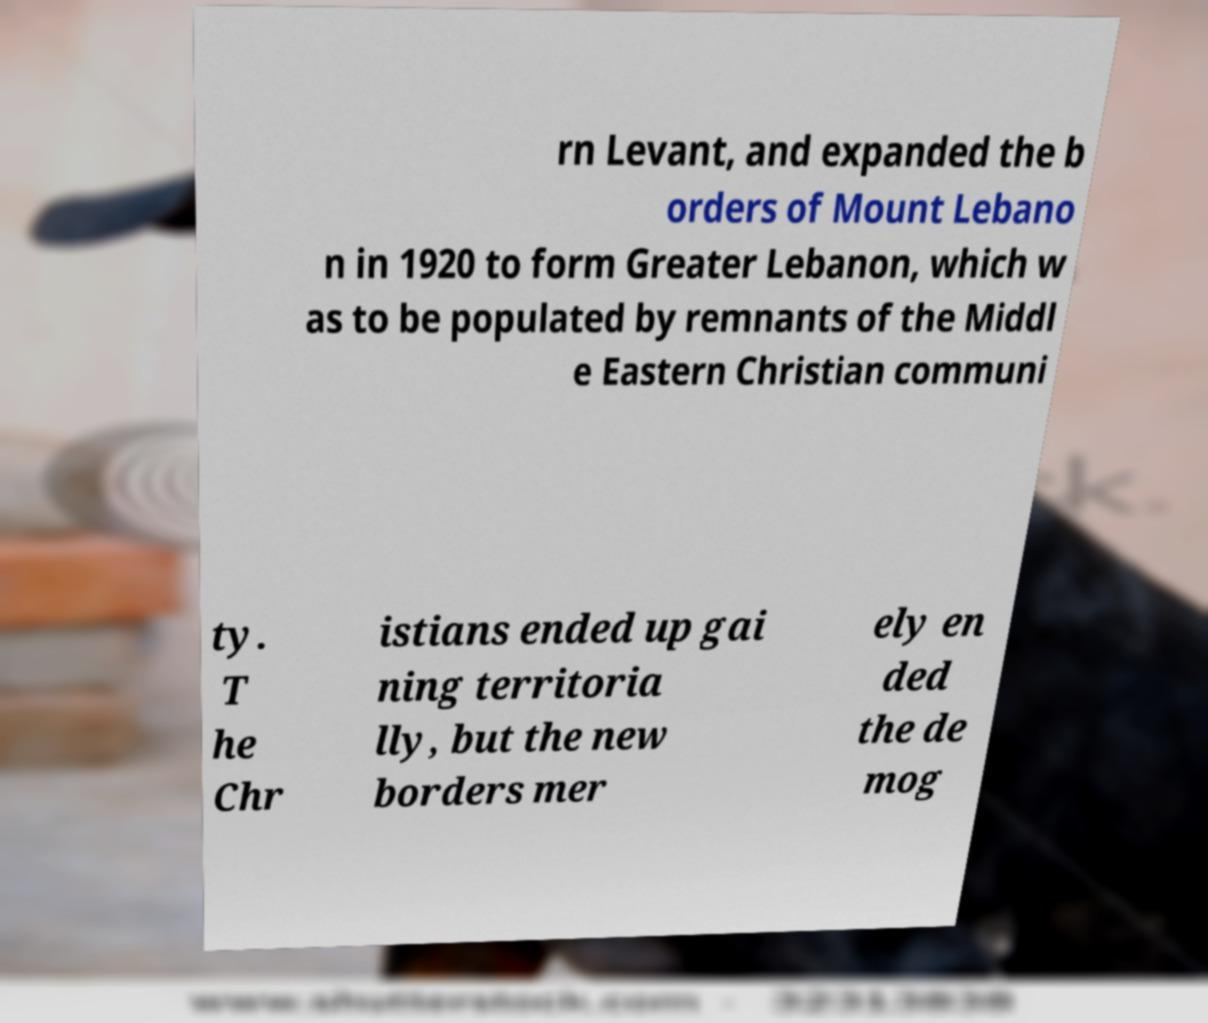There's text embedded in this image that I need extracted. Can you transcribe it verbatim? rn Levant, and expanded the b orders of Mount Lebano n in 1920 to form Greater Lebanon, which w as to be populated by remnants of the Middl e Eastern Christian communi ty. T he Chr istians ended up gai ning territoria lly, but the new borders mer ely en ded the de mog 